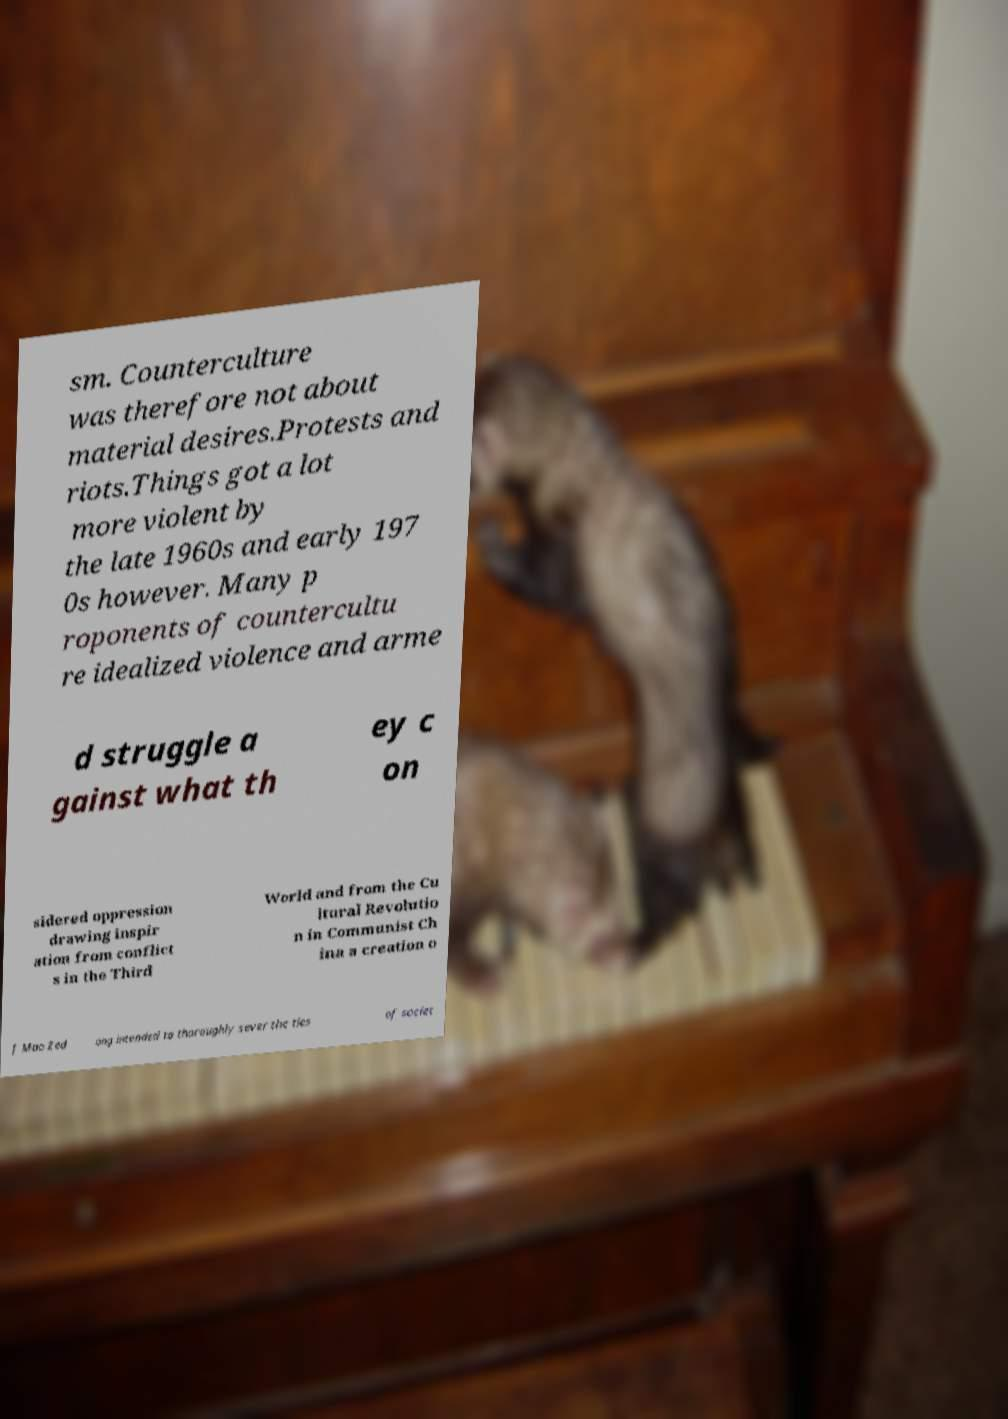Please identify and transcribe the text found in this image. sm. Counterculture was therefore not about material desires.Protests and riots.Things got a lot more violent by the late 1960s and early 197 0s however. Many p roponents of countercultu re idealized violence and arme d struggle a gainst what th ey c on sidered oppression drawing inspir ation from conflict s in the Third World and from the Cu ltural Revolutio n in Communist Ch ina a creation o f Mao Zed ong intended to thoroughly sever the ties of societ 